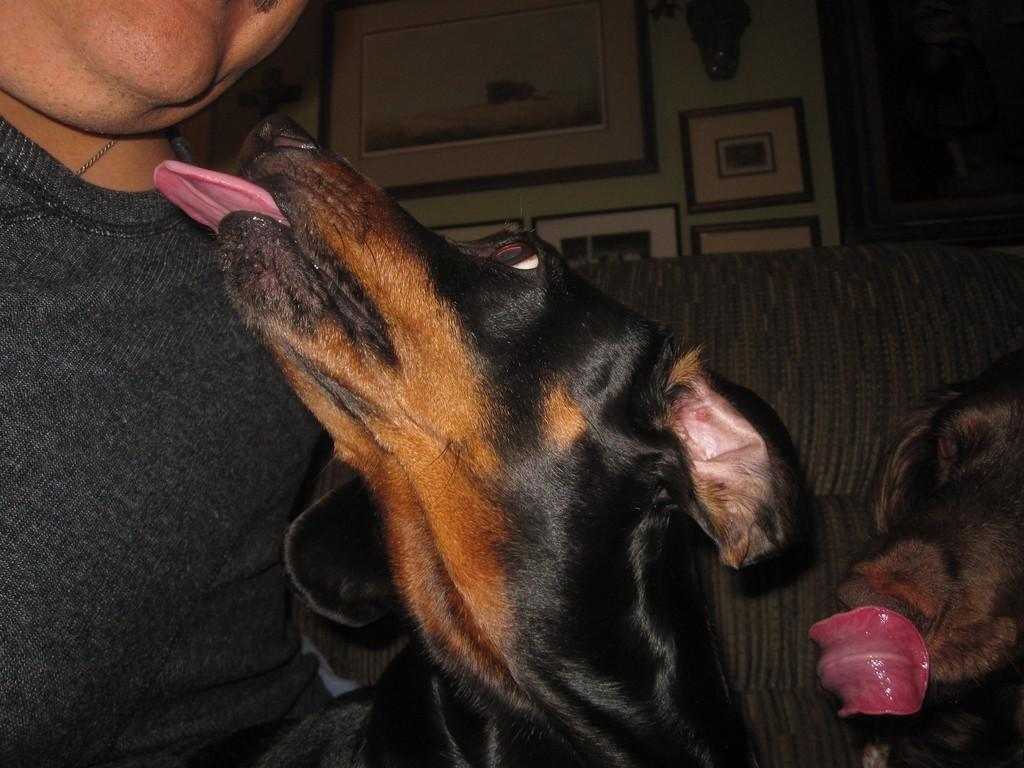Who or what is present in the image? There is a person and two dogs in the image. What type of furniture is in the image? There is a couch in the image. What can be seen on the wall in the image? There are frames attached to the wall in the image. What arithmetic problem is the person solving in the image? There is no arithmetic problem visible in the image. How does the bridge connect the two sides in the image? There is no bridge present in the image. 